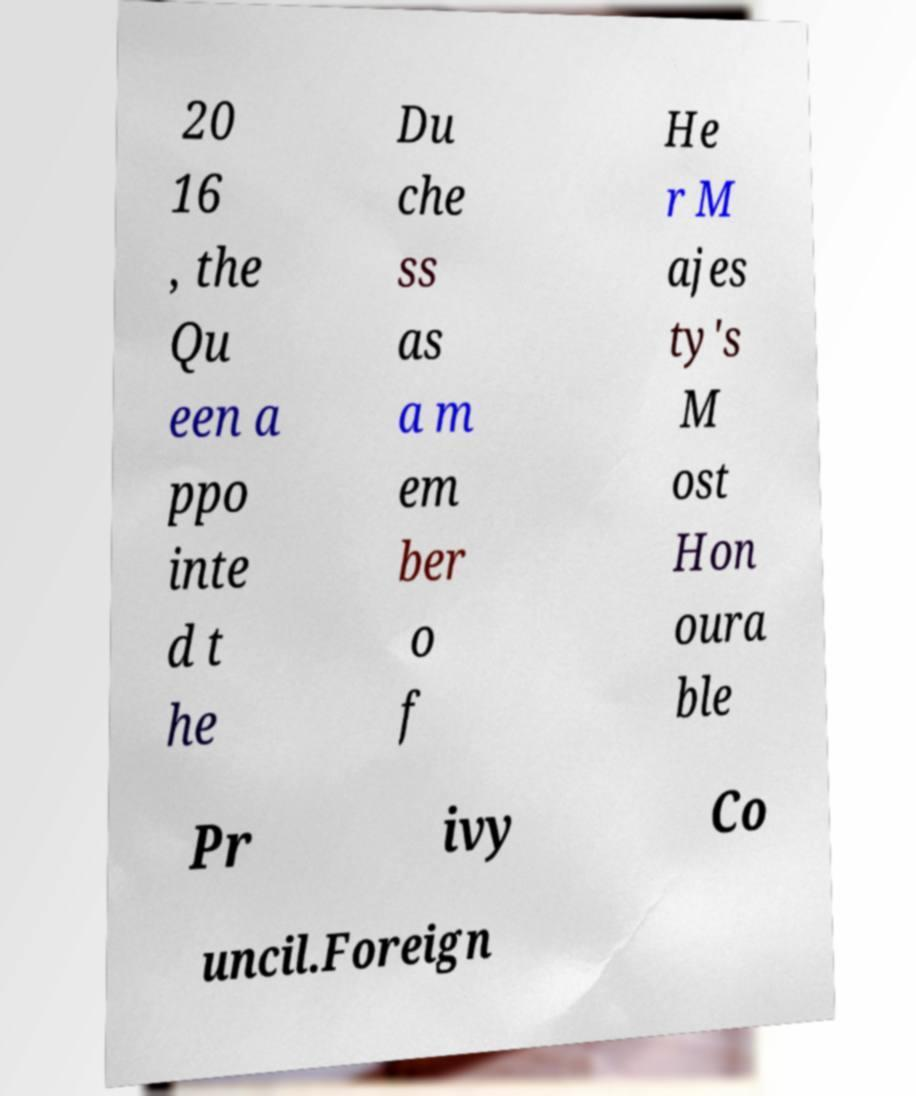Can you read and provide the text displayed in the image?This photo seems to have some interesting text. Can you extract and type it out for me? 20 16 , the Qu een a ppo inte d t he Du che ss as a m em ber o f He r M ajes ty's M ost Hon oura ble Pr ivy Co uncil.Foreign 